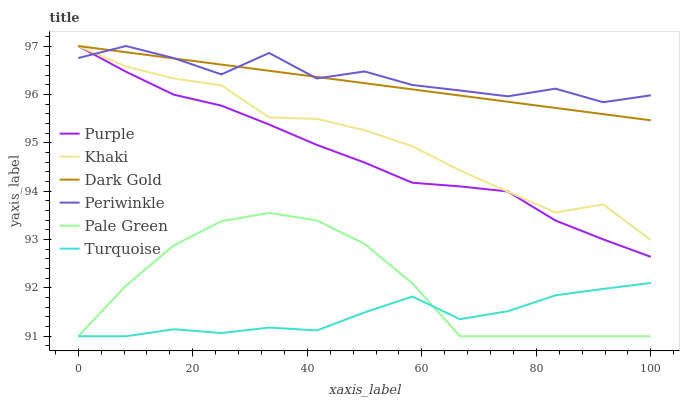Does Khaki have the minimum area under the curve?
Answer yes or no. No. Does Khaki have the maximum area under the curve?
Answer yes or no. No. Is Khaki the smoothest?
Answer yes or no. No. Is Khaki the roughest?
Answer yes or no. No. Does Khaki have the lowest value?
Answer yes or no. No. Does Pale Green have the highest value?
Answer yes or no. No. Is Turquoise less than Khaki?
Answer yes or no. Yes. Is Periwinkle greater than Turquoise?
Answer yes or no. Yes. Does Turquoise intersect Khaki?
Answer yes or no. No. 